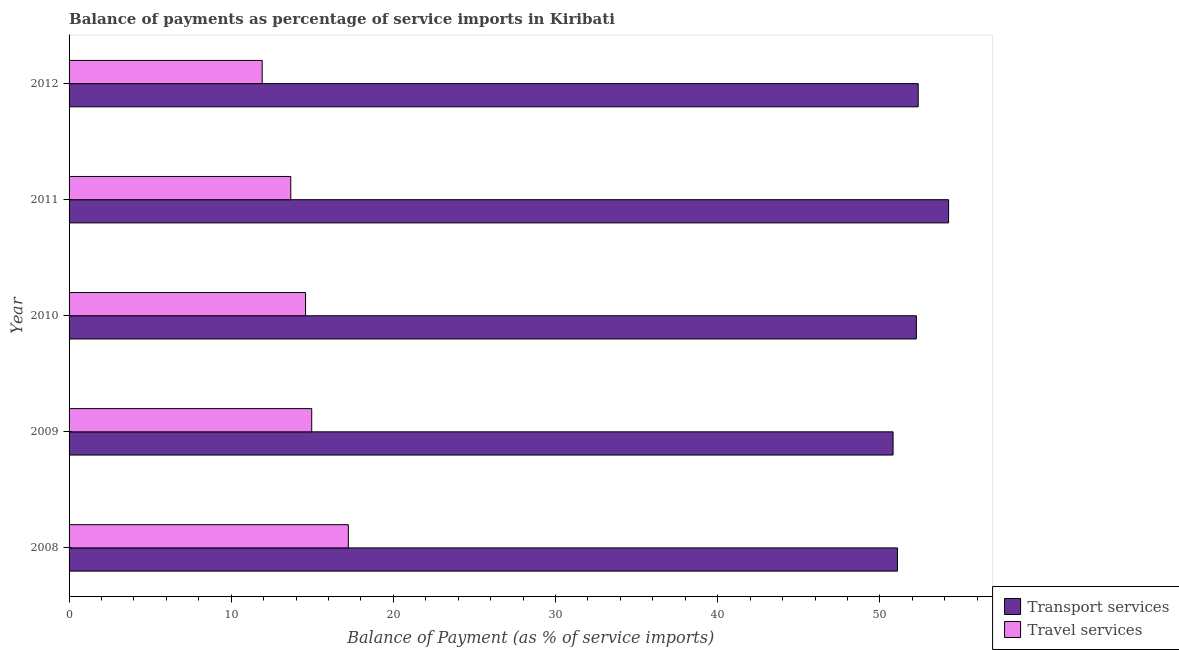Are the number of bars per tick equal to the number of legend labels?
Ensure brevity in your answer.  Yes. Are the number of bars on each tick of the Y-axis equal?
Give a very brief answer. Yes. How many bars are there on the 2nd tick from the top?
Your answer should be very brief. 2. How many bars are there on the 5th tick from the bottom?
Your answer should be very brief. 2. In how many cases, is the number of bars for a given year not equal to the number of legend labels?
Your answer should be very brief. 0. What is the balance of payments of travel services in 2010?
Give a very brief answer. 14.58. Across all years, what is the maximum balance of payments of travel services?
Keep it short and to the point. 17.22. Across all years, what is the minimum balance of payments of travel services?
Your answer should be very brief. 11.91. In which year was the balance of payments of travel services minimum?
Offer a very short reply. 2012. What is the total balance of payments of travel services in the graph?
Give a very brief answer. 72.35. What is the difference between the balance of payments of travel services in 2010 and that in 2011?
Make the answer very short. 0.91. What is the difference between the balance of payments of travel services in 2012 and the balance of payments of transport services in 2010?
Give a very brief answer. -40.34. What is the average balance of payments of travel services per year?
Provide a succinct answer. 14.47. In the year 2010, what is the difference between the balance of payments of travel services and balance of payments of transport services?
Offer a very short reply. -37.67. What is the ratio of the balance of payments of transport services in 2008 to that in 2011?
Your answer should be very brief. 0.94. Is the difference between the balance of payments of travel services in 2008 and 2012 greater than the difference between the balance of payments of transport services in 2008 and 2012?
Offer a terse response. Yes. What is the difference between the highest and the second highest balance of payments of transport services?
Keep it short and to the point. 1.87. What is the difference between the highest and the lowest balance of payments of transport services?
Ensure brevity in your answer.  3.42. Is the sum of the balance of payments of travel services in 2008 and 2012 greater than the maximum balance of payments of transport services across all years?
Give a very brief answer. No. What does the 1st bar from the top in 2009 represents?
Give a very brief answer. Travel services. What does the 2nd bar from the bottom in 2012 represents?
Your answer should be compact. Travel services. Are all the bars in the graph horizontal?
Ensure brevity in your answer.  Yes. How many years are there in the graph?
Provide a succinct answer. 5. Are the values on the major ticks of X-axis written in scientific E-notation?
Give a very brief answer. No. Does the graph contain any zero values?
Provide a succinct answer. No. What is the title of the graph?
Keep it short and to the point. Balance of payments as percentage of service imports in Kiribati. Does "Working capital" appear as one of the legend labels in the graph?
Ensure brevity in your answer.  No. What is the label or title of the X-axis?
Your answer should be compact. Balance of Payment (as % of service imports). What is the label or title of the Y-axis?
Offer a terse response. Year. What is the Balance of Payment (as % of service imports) in Transport services in 2008?
Your answer should be very brief. 51.08. What is the Balance of Payment (as % of service imports) in Travel services in 2008?
Keep it short and to the point. 17.22. What is the Balance of Payment (as % of service imports) of Transport services in 2009?
Provide a short and direct response. 50.81. What is the Balance of Payment (as % of service imports) in Travel services in 2009?
Offer a terse response. 14.96. What is the Balance of Payment (as % of service imports) in Transport services in 2010?
Your response must be concise. 52.25. What is the Balance of Payment (as % of service imports) of Travel services in 2010?
Make the answer very short. 14.58. What is the Balance of Payment (as % of service imports) of Transport services in 2011?
Provide a short and direct response. 54.24. What is the Balance of Payment (as % of service imports) in Travel services in 2011?
Offer a terse response. 13.67. What is the Balance of Payment (as % of service imports) of Transport services in 2012?
Your answer should be compact. 52.36. What is the Balance of Payment (as % of service imports) in Travel services in 2012?
Offer a very short reply. 11.91. Across all years, what is the maximum Balance of Payment (as % of service imports) in Transport services?
Offer a terse response. 54.24. Across all years, what is the maximum Balance of Payment (as % of service imports) in Travel services?
Offer a very short reply. 17.22. Across all years, what is the minimum Balance of Payment (as % of service imports) in Transport services?
Provide a short and direct response. 50.81. Across all years, what is the minimum Balance of Payment (as % of service imports) in Travel services?
Offer a very short reply. 11.91. What is the total Balance of Payment (as % of service imports) of Transport services in the graph?
Provide a succinct answer. 260.75. What is the total Balance of Payment (as % of service imports) in Travel services in the graph?
Offer a very short reply. 72.35. What is the difference between the Balance of Payment (as % of service imports) in Transport services in 2008 and that in 2009?
Your response must be concise. 0.27. What is the difference between the Balance of Payment (as % of service imports) of Travel services in 2008 and that in 2009?
Give a very brief answer. 2.26. What is the difference between the Balance of Payment (as % of service imports) of Transport services in 2008 and that in 2010?
Provide a succinct answer. -1.17. What is the difference between the Balance of Payment (as % of service imports) of Travel services in 2008 and that in 2010?
Make the answer very short. 2.64. What is the difference between the Balance of Payment (as % of service imports) of Transport services in 2008 and that in 2011?
Your answer should be compact. -3.15. What is the difference between the Balance of Payment (as % of service imports) of Travel services in 2008 and that in 2011?
Provide a succinct answer. 3.55. What is the difference between the Balance of Payment (as % of service imports) of Transport services in 2008 and that in 2012?
Make the answer very short. -1.28. What is the difference between the Balance of Payment (as % of service imports) of Travel services in 2008 and that in 2012?
Your response must be concise. 5.31. What is the difference between the Balance of Payment (as % of service imports) of Transport services in 2009 and that in 2010?
Ensure brevity in your answer.  -1.44. What is the difference between the Balance of Payment (as % of service imports) in Travel services in 2009 and that in 2010?
Your answer should be compact. 0.38. What is the difference between the Balance of Payment (as % of service imports) in Transport services in 2009 and that in 2011?
Provide a succinct answer. -3.42. What is the difference between the Balance of Payment (as % of service imports) of Travel services in 2009 and that in 2011?
Offer a terse response. 1.29. What is the difference between the Balance of Payment (as % of service imports) of Transport services in 2009 and that in 2012?
Offer a very short reply. -1.55. What is the difference between the Balance of Payment (as % of service imports) in Travel services in 2009 and that in 2012?
Provide a short and direct response. 3.05. What is the difference between the Balance of Payment (as % of service imports) in Transport services in 2010 and that in 2011?
Give a very brief answer. -1.99. What is the difference between the Balance of Payment (as % of service imports) of Travel services in 2010 and that in 2011?
Your response must be concise. 0.91. What is the difference between the Balance of Payment (as % of service imports) in Transport services in 2010 and that in 2012?
Offer a very short reply. -0.11. What is the difference between the Balance of Payment (as % of service imports) of Travel services in 2010 and that in 2012?
Your answer should be compact. 2.67. What is the difference between the Balance of Payment (as % of service imports) of Transport services in 2011 and that in 2012?
Offer a very short reply. 1.87. What is the difference between the Balance of Payment (as % of service imports) of Travel services in 2011 and that in 2012?
Your response must be concise. 1.76. What is the difference between the Balance of Payment (as % of service imports) of Transport services in 2008 and the Balance of Payment (as % of service imports) of Travel services in 2009?
Offer a very short reply. 36.12. What is the difference between the Balance of Payment (as % of service imports) of Transport services in 2008 and the Balance of Payment (as % of service imports) of Travel services in 2010?
Provide a succinct answer. 36.5. What is the difference between the Balance of Payment (as % of service imports) in Transport services in 2008 and the Balance of Payment (as % of service imports) in Travel services in 2011?
Offer a very short reply. 37.41. What is the difference between the Balance of Payment (as % of service imports) of Transport services in 2008 and the Balance of Payment (as % of service imports) of Travel services in 2012?
Make the answer very short. 39.17. What is the difference between the Balance of Payment (as % of service imports) of Transport services in 2009 and the Balance of Payment (as % of service imports) of Travel services in 2010?
Your response must be concise. 36.23. What is the difference between the Balance of Payment (as % of service imports) in Transport services in 2009 and the Balance of Payment (as % of service imports) in Travel services in 2011?
Make the answer very short. 37.14. What is the difference between the Balance of Payment (as % of service imports) of Transport services in 2009 and the Balance of Payment (as % of service imports) of Travel services in 2012?
Your answer should be very brief. 38.9. What is the difference between the Balance of Payment (as % of service imports) in Transport services in 2010 and the Balance of Payment (as % of service imports) in Travel services in 2011?
Your response must be concise. 38.58. What is the difference between the Balance of Payment (as % of service imports) in Transport services in 2010 and the Balance of Payment (as % of service imports) in Travel services in 2012?
Provide a succinct answer. 40.34. What is the difference between the Balance of Payment (as % of service imports) of Transport services in 2011 and the Balance of Payment (as % of service imports) of Travel services in 2012?
Your answer should be very brief. 42.33. What is the average Balance of Payment (as % of service imports) of Transport services per year?
Give a very brief answer. 52.15. What is the average Balance of Payment (as % of service imports) of Travel services per year?
Make the answer very short. 14.47. In the year 2008, what is the difference between the Balance of Payment (as % of service imports) of Transport services and Balance of Payment (as % of service imports) of Travel services?
Give a very brief answer. 33.86. In the year 2009, what is the difference between the Balance of Payment (as % of service imports) of Transport services and Balance of Payment (as % of service imports) of Travel services?
Your answer should be very brief. 35.85. In the year 2010, what is the difference between the Balance of Payment (as % of service imports) of Transport services and Balance of Payment (as % of service imports) of Travel services?
Provide a succinct answer. 37.67. In the year 2011, what is the difference between the Balance of Payment (as % of service imports) of Transport services and Balance of Payment (as % of service imports) of Travel services?
Your answer should be very brief. 40.56. In the year 2012, what is the difference between the Balance of Payment (as % of service imports) in Transport services and Balance of Payment (as % of service imports) in Travel services?
Make the answer very short. 40.45. What is the ratio of the Balance of Payment (as % of service imports) in Transport services in 2008 to that in 2009?
Keep it short and to the point. 1.01. What is the ratio of the Balance of Payment (as % of service imports) of Travel services in 2008 to that in 2009?
Make the answer very short. 1.15. What is the ratio of the Balance of Payment (as % of service imports) in Transport services in 2008 to that in 2010?
Your response must be concise. 0.98. What is the ratio of the Balance of Payment (as % of service imports) in Travel services in 2008 to that in 2010?
Your answer should be compact. 1.18. What is the ratio of the Balance of Payment (as % of service imports) of Transport services in 2008 to that in 2011?
Provide a succinct answer. 0.94. What is the ratio of the Balance of Payment (as % of service imports) in Travel services in 2008 to that in 2011?
Your answer should be compact. 1.26. What is the ratio of the Balance of Payment (as % of service imports) in Transport services in 2008 to that in 2012?
Keep it short and to the point. 0.98. What is the ratio of the Balance of Payment (as % of service imports) in Travel services in 2008 to that in 2012?
Your answer should be compact. 1.45. What is the ratio of the Balance of Payment (as % of service imports) in Transport services in 2009 to that in 2010?
Your answer should be very brief. 0.97. What is the ratio of the Balance of Payment (as % of service imports) of Transport services in 2009 to that in 2011?
Provide a succinct answer. 0.94. What is the ratio of the Balance of Payment (as % of service imports) in Travel services in 2009 to that in 2011?
Keep it short and to the point. 1.09. What is the ratio of the Balance of Payment (as % of service imports) of Transport services in 2009 to that in 2012?
Keep it short and to the point. 0.97. What is the ratio of the Balance of Payment (as % of service imports) in Travel services in 2009 to that in 2012?
Your answer should be compact. 1.26. What is the ratio of the Balance of Payment (as % of service imports) of Transport services in 2010 to that in 2011?
Provide a short and direct response. 0.96. What is the ratio of the Balance of Payment (as % of service imports) of Travel services in 2010 to that in 2011?
Provide a short and direct response. 1.07. What is the ratio of the Balance of Payment (as % of service imports) in Travel services in 2010 to that in 2012?
Make the answer very short. 1.22. What is the ratio of the Balance of Payment (as % of service imports) of Transport services in 2011 to that in 2012?
Make the answer very short. 1.04. What is the ratio of the Balance of Payment (as % of service imports) in Travel services in 2011 to that in 2012?
Your answer should be compact. 1.15. What is the difference between the highest and the second highest Balance of Payment (as % of service imports) of Transport services?
Make the answer very short. 1.87. What is the difference between the highest and the second highest Balance of Payment (as % of service imports) in Travel services?
Your response must be concise. 2.26. What is the difference between the highest and the lowest Balance of Payment (as % of service imports) of Transport services?
Offer a terse response. 3.42. What is the difference between the highest and the lowest Balance of Payment (as % of service imports) of Travel services?
Offer a terse response. 5.31. 